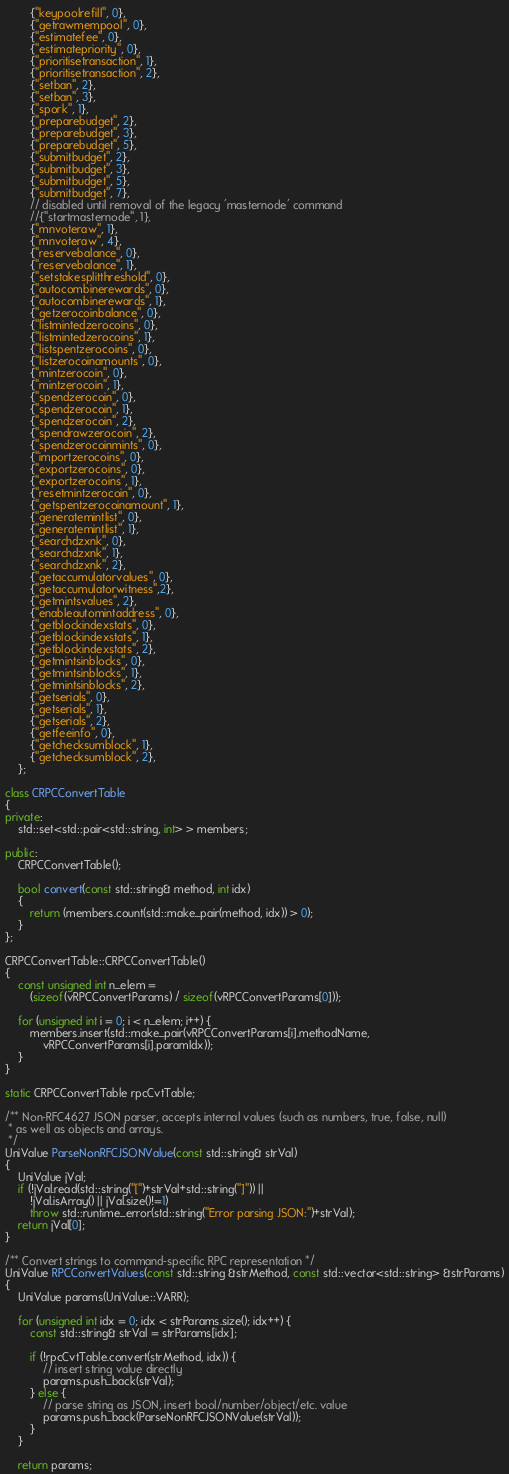<code> <loc_0><loc_0><loc_500><loc_500><_C++_>        {"keypoolrefill", 0},
        {"getrawmempool", 0},
        {"estimatefee", 0},
        {"estimatepriority", 0},
        {"prioritisetransaction", 1},
        {"prioritisetransaction", 2},
        {"setban", 2},
        {"setban", 3},
        {"spork", 1},
        {"preparebudget", 2},
        {"preparebudget", 3},
        {"preparebudget", 5},
        {"submitbudget", 2},
        {"submitbudget", 3},
        {"submitbudget", 5},
        {"submitbudget", 7},
        // disabled until removal of the legacy 'masternode' command
        //{"startmasternode", 1},
        {"mnvoteraw", 1},
        {"mnvoteraw", 4},
        {"reservebalance", 0},
        {"reservebalance", 1},
        {"setstakesplitthreshold", 0},
        {"autocombinerewards", 0},
        {"autocombinerewards", 1},
        {"getzerocoinbalance", 0},
        {"listmintedzerocoins", 0},
        {"listmintedzerocoins", 1},
        {"listspentzerocoins", 0},
        {"listzerocoinamounts", 0},
        {"mintzerocoin", 0},
        {"mintzerocoin", 1},
        {"spendzerocoin", 0},
        {"spendzerocoin", 1},
        {"spendzerocoin", 2},
        {"spendrawzerocoin", 2},
        {"spendzerocoinmints", 0},
        {"importzerocoins", 0},
        {"exportzerocoins", 0},
        {"exportzerocoins", 1},
        {"resetmintzerocoin", 0},
        {"getspentzerocoinamount", 1},
        {"generatemintlist", 0},
        {"generatemintlist", 1},
        {"searchdzxnk", 0},
        {"searchdzxnk", 1},
        {"searchdzxnk", 2},
        {"getaccumulatorvalues", 0},
        {"getaccumulatorwitness",2},
        {"getmintsvalues", 2},
        {"enableautomintaddress", 0},
        {"getblockindexstats", 0},
        {"getblockindexstats", 1},
        {"getblockindexstats", 2},
        {"getmintsinblocks", 0},
        {"getmintsinblocks", 1},
        {"getmintsinblocks", 2},
        {"getserials", 0},
        {"getserials", 1},
        {"getserials", 2},
        {"getfeeinfo", 0},
        {"getchecksumblock", 1},
        {"getchecksumblock", 2},
    };

class CRPCConvertTable
{
private:
    std::set<std::pair<std::string, int> > members;

public:
    CRPCConvertTable();

    bool convert(const std::string& method, int idx)
    {
        return (members.count(std::make_pair(method, idx)) > 0);
    }
};

CRPCConvertTable::CRPCConvertTable()
{
    const unsigned int n_elem =
        (sizeof(vRPCConvertParams) / sizeof(vRPCConvertParams[0]));

    for (unsigned int i = 0; i < n_elem; i++) {
        members.insert(std::make_pair(vRPCConvertParams[i].methodName,
            vRPCConvertParams[i].paramIdx));
    }
}

static CRPCConvertTable rpcCvtTable;

/** Non-RFC4627 JSON parser, accepts internal values (such as numbers, true, false, null)
 * as well as objects and arrays.
 */
UniValue ParseNonRFCJSONValue(const std::string& strVal)
{
    UniValue jVal;
    if (!jVal.read(std::string("[")+strVal+std::string("]")) ||
        !jVal.isArray() || jVal.size()!=1)
        throw std::runtime_error(std::string("Error parsing JSON:")+strVal);
    return jVal[0];
}

/** Convert strings to command-specific RPC representation */
UniValue RPCConvertValues(const std::string &strMethod, const std::vector<std::string> &strParams)
{
    UniValue params(UniValue::VARR);

    for (unsigned int idx = 0; idx < strParams.size(); idx++) {
        const std::string& strVal = strParams[idx];

        if (!rpcCvtTable.convert(strMethod, idx)) {
            // insert string value directly
            params.push_back(strVal);
        } else {
            // parse string as JSON, insert bool/number/object/etc. value
            params.push_back(ParseNonRFCJSONValue(strVal));
        }
    }

    return params;</code> 